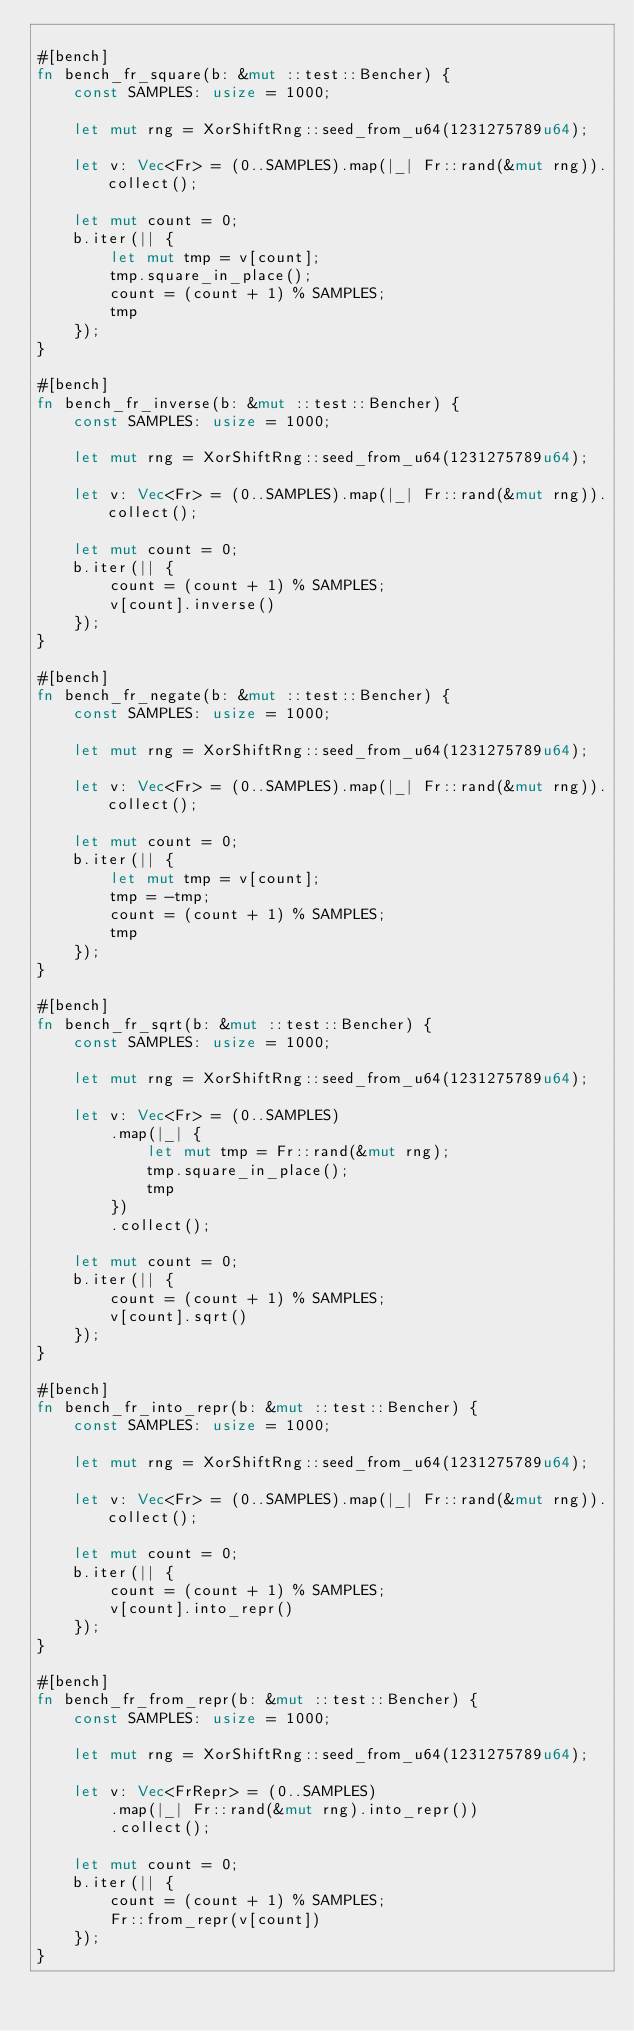Convert code to text. <code><loc_0><loc_0><loc_500><loc_500><_Rust_>
#[bench]
fn bench_fr_square(b: &mut ::test::Bencher) {
    const SAMPLES: usize = 1000;

    let mut rng = XorShiftRng::seed_from_u64(1231275789u64);

    let v: Vec<Fr> = (0..SAMPLES).map(|_| Fr::rand(&mut rng)).collect();

    let mut count = 0;
    b.iter(|| {
        let mut tmp = v[count];
        tmp.square_in_place();
        count = (count + 1) % SAMPLES;
        tmp
    });
}

#[bench]
fn bench_fr_inverse(b: &mut ::test::Bencher) {
    const SAMPLES: usize = 1000;

    let mut rng = XorShiftRng::seed_from_u64(1231275789u64);

    let v: Vec<Fr> = (0..SAMPLES).map(|_| Fr::rand(&mut rng)).collect();

    let mut count = 0;
    b.iter(|| {
        count = (count + 1) % SAMPLES;
        v[count].inverse()
    });
}

#[bench]
fn bench_fr_negate(b: &mut ::test::Bencher) {
    const SAMPLES: usize = 1000;

    let mut rng = XorShiftRng::seed_from_u64(1231275789u64);

    let v: Vec<Fr> = (0..SAMPLES).map(|_| Fr::rand(&mut rng)).collect();

    let mut count = 0;
    b.iter(|| {
        let mut tmp = v[count];
        tmp = -tmp;
        count = (count + 1) % SAMPLES;
        tmp
    });
}

#[bench]
fn bench_fr_sqrt(b: &mut ::test::Bencher) {
    const SAMPLES: usize = 1000;

    let mut rng = XorShiftRng::seed_from_u64(1231275789u64);

    let v: Vec<Fr> = (0..SAMPLES)
        .map(|_| {
            let mut tmp = Fr::rand(&mut rng);
            tmp.square_in_place();
            tmp
        })
        .collect();

    let mut count = 0;
    b.iter(|| {
        count = (count + 1) % SAMPLES;
        v[count].sqrt()
    });
}

#[bench]
fn bench_fr_into_repr(b: &mut ::test::Bencher) {
    const SAMPLES: usize = 1000;

    let mut rng = XorShiftRng::seed_from_u64(1231275789u64);

    let v: Vec<Fr> = (0..SAMPLES).map(|_| Fr::rand(&mut rng)).collect();

    let mut count = 0;
    b.iter(|| {
        count = (count + 1) % SAMPLES;
        v[count].into_repr()
    });
}

#[bench]
fn bench_fr_from_repr(b: &mut ::test::Bencher) {
    const SAMPLES: usize = 1000;

    let mut rng = XorShiftRng::seed_from_u64(1231275789u64);

    let v: Vec<FrRepr> = (0..SAMPLES)
        .map(|_| Fr::rand(&mut rng).into_repr())
        .collect();

    let mut count = 0;
    b.iter(|| {
        count = (count + 1) % SAMPLES;
        Fr::from_repr(v[count])
    });
}</code> 